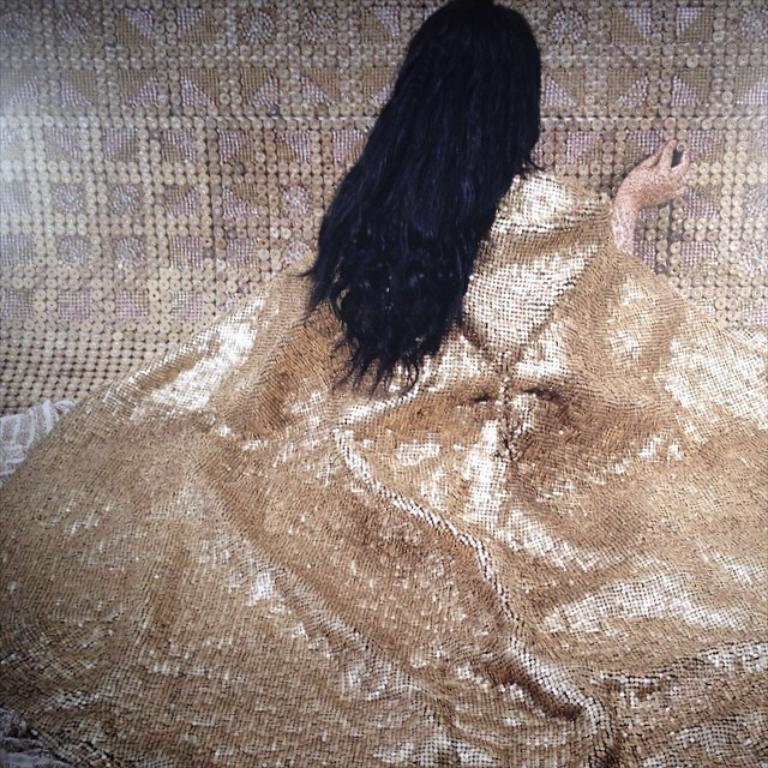What is the main subject of the image? There is a sculpture of a woman in the image. What type of pancake is being exchanged in the image? There is no pancake or exchange present in the image; it features a sculpture of a woman. What type of chain is visible around the neck of the woman in the image? There is no chain visible around the neck of the woman in the image; it is a sculpture, and sculptures do not typically have accessories like chains. 